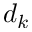Convert formula to latex. <formula><loc_0><loc_0><loc_500><loc_500>d _ { k }</formula> 